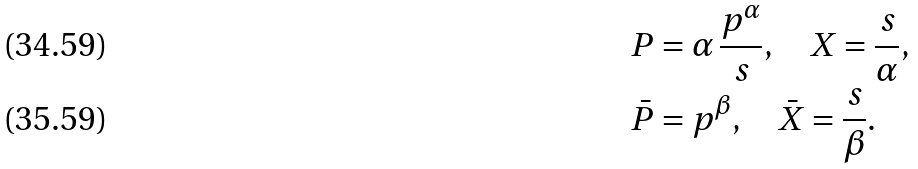Convert formula to latex. <formula><loc_0><loc_0><loc_500><loc_500>& P = \alpha \, \frac { p ^ { \alpha } } { s } , \quad X = \frac { s } { \alpha } , \\ & \bar { P } = p ^ { \beta } , \quad \bar { X } = \frac { s } { \beta } .</formula> 